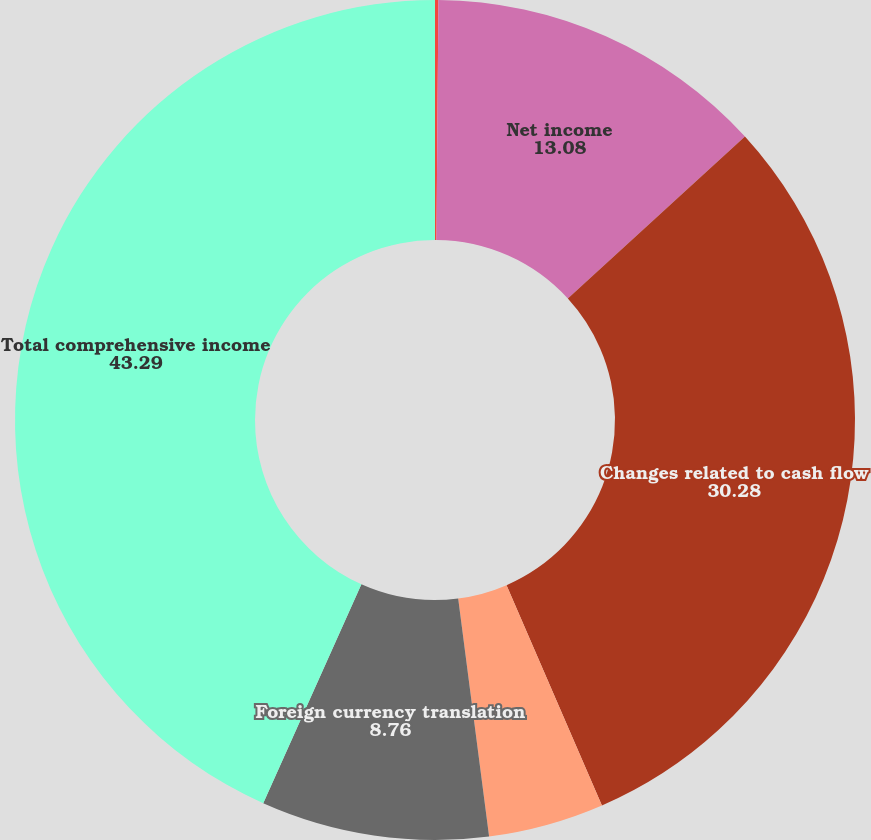Convert chart to OTSL. <chart><loc_0><loc_0><loc_500><loc_500><pie_chart><fcel>Year Ended December 31<fcel>Net income<fcel>Changes related to cash flow<fcel>Change in defined benefit<fcel>Foreign currency translation<fcel>Total comprehensive income<nl><fcel>0.13%<fcel>13.08%<fcel>30.28%<fcel>4.45%<fcel>8.76%<fcel>43.29%<nl></chart> 